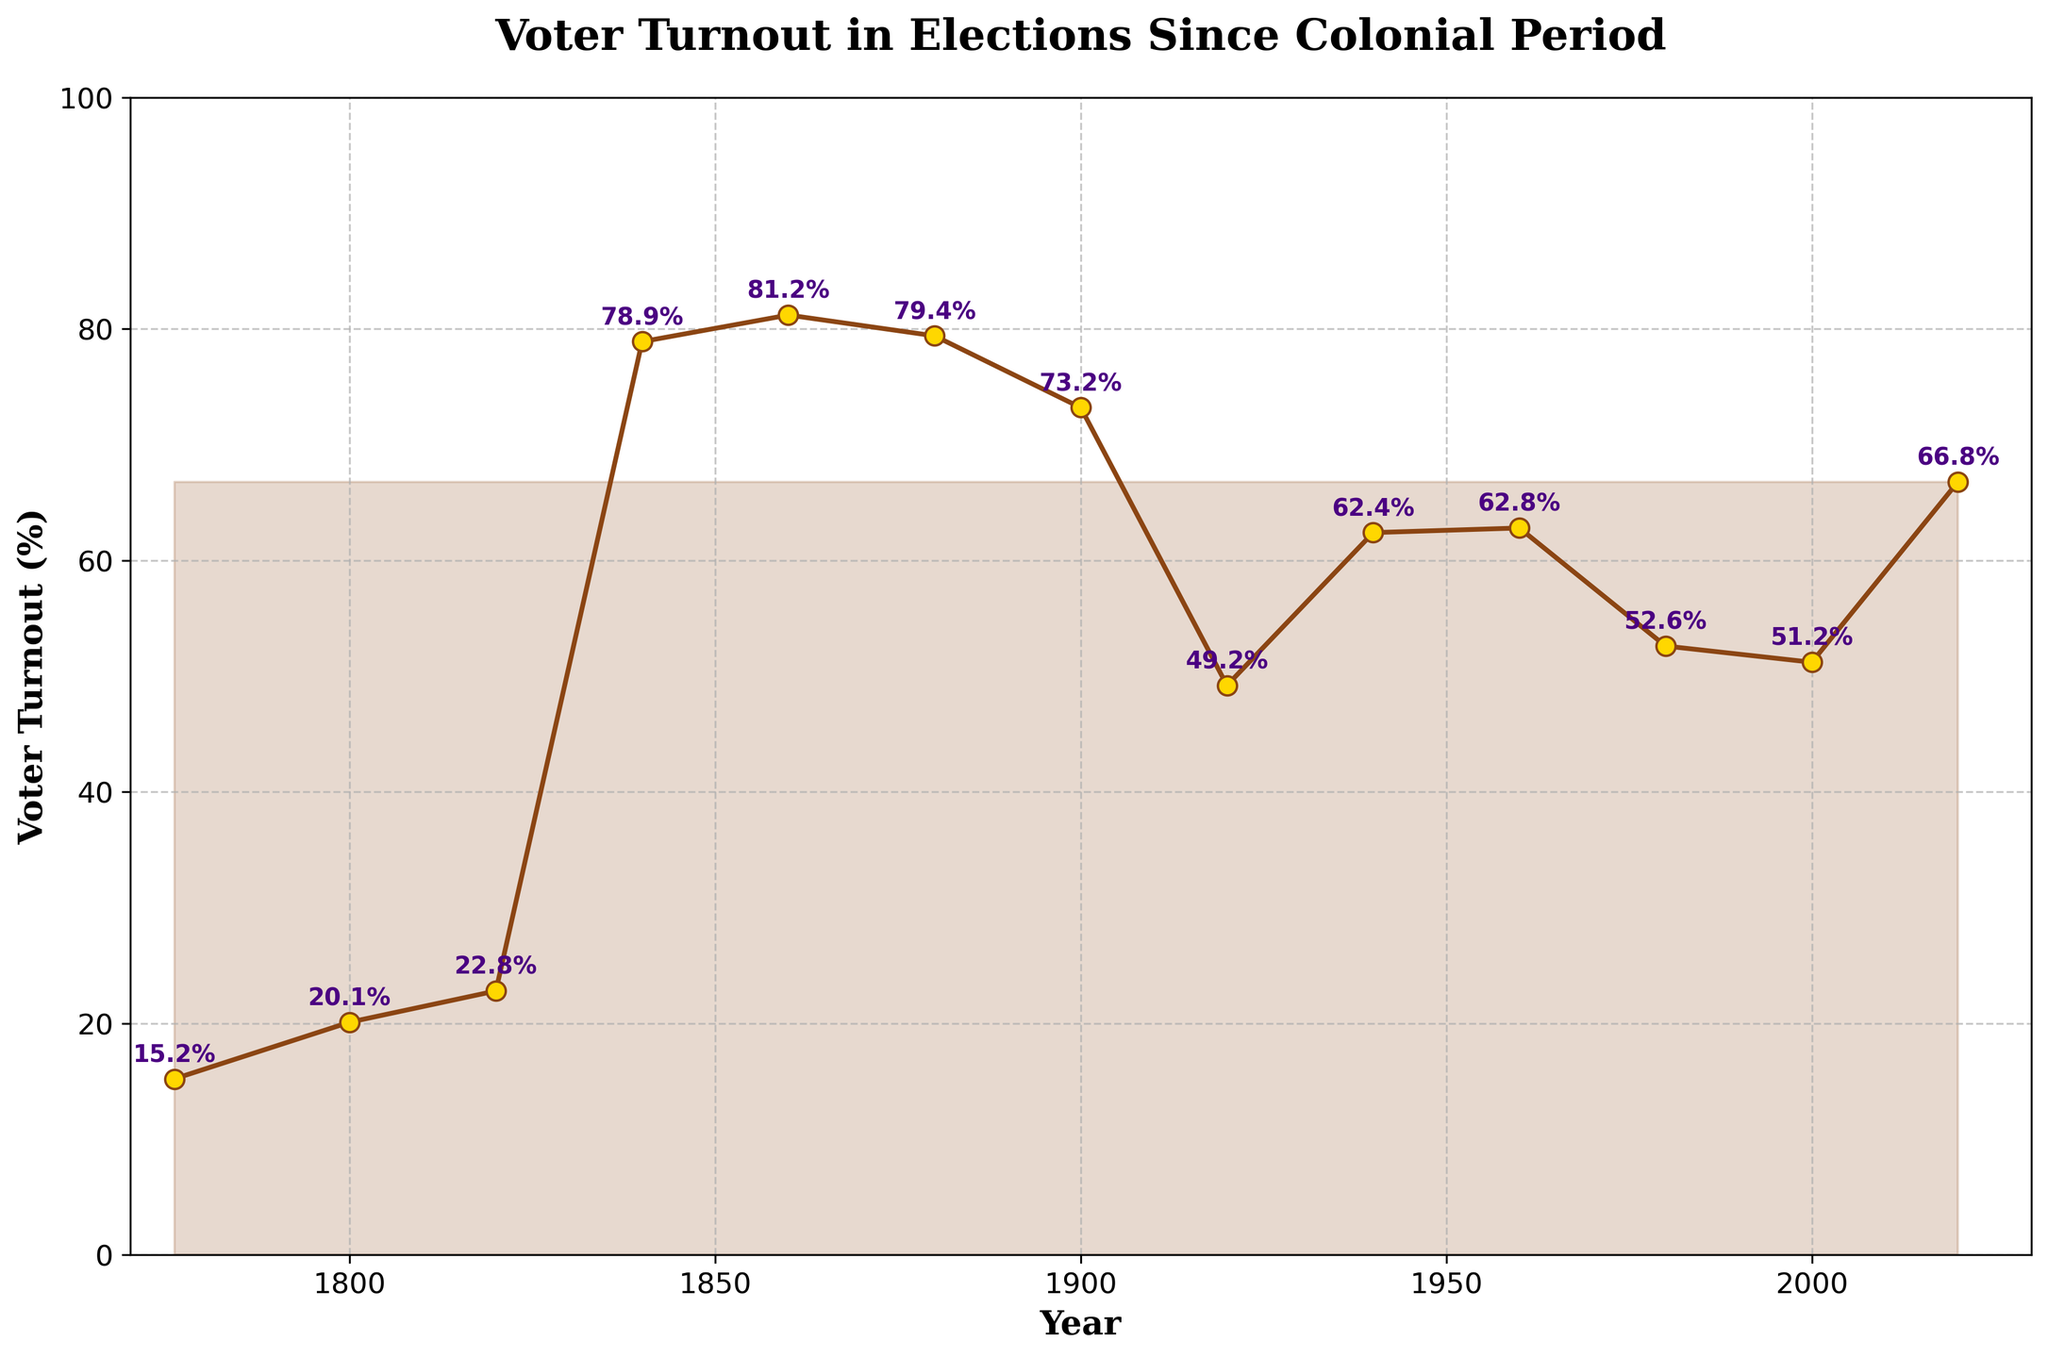What year recorded the highest voter turnout? Examining the plot, the highest voter turnout percentage is 81.2%, which occurs at the year label 1860.
Answer: 1860 How does the voter turnout in 1840 compare to that in 1800? In 1840, the voter turnout is 78.9%, while in 1800, it is 20.1%. Clearly, voter turnout in 1840 is significantly higher than in 1800.
Answer: Voter turnout in 1840 is much higher What is the average voter turnout percentage from 1900 to 1940? The voter turnout percentages from 1900 to 1940 are 73.2% (1900), 49.2% (1920), and 62.4% (1940). Calculating the average: (73.2 + 49.2 + 62.4) / 3 = 61.6.
Answer: 61.6% Which decade experiences the lowest voter turnout percentage, and what is the value? By examining the plot, the lowest voter turnout percentage is 15.2%, in the year 1776. Since this is a single year rather than a decade, it can be inferred that no specific decade holds the lowest turnout, rather this individual year does.
Answer: 1776, 15.2% What is the rate of change in voter turnout from 2000 to 2020? The voter turnout in 2000 is 51.2% and in 2020, it is 66.8%. The rate of change can be calculated as (66.8 - 51.2) = 15.6%.
Answer: 15.6% Compare the voter turnout in 1880 to that in 1900. Voter turnout in 1880 is 79.4%, and in 1900, it is 73.2%. Thus, voter turnout in 1880 is higher compared to 1900.
Answer: Voter turnout in 1880 is higher What trend is observed in voter turnout from the start (1776) to 1840? The voter turnout increases significantly from 15.2% in 1776 to 78.9% in 1840.
Answer: Increasing trend How many times did the voter turnout exceed 60% from 1800 to 2000, inclusively? The years with voter turnout exceeding 60% in this period are 1840 (78.9%), 1860 (81.2%), 1880 (79.4%), 1900 (73.2%), 1940 (62.4%), and 1960 (62.8%). Count: 6 times.
Answer: 6 times 